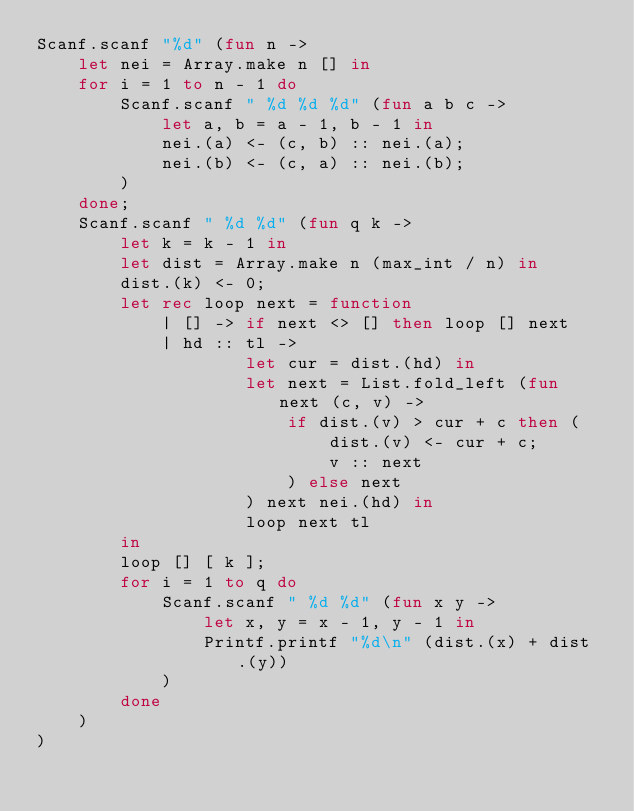<code> <loc_0><loc_0><loc_500><loc_500><_OCaml_>Scanf.scanf "%d" (fun n ->
    let nei = Array.make n [] in
    for i = 1 to n - 1 do
        Scanf.scanf " %d %d %d" (fun a b c ->
            let a, b = a - 1, b - 1 in
            nei.(a) <- (c, b) :: nei.(a);
            nei.(b) <- (c, a) :: nei.(b);
        )
    done;
    Scanf.scanf " %d %d" (fun q k ->
        let k = k - 1 in
        let dist = Array.make n (max_int / n) in
        dist.(k) <- 0;
        let rec loop next = function
            | [] -> if next <> [] then loop [] next
            | hd :: tl ->
                    let cur = dist.(hd) in
                    let next = List.fold_left (fun next (c, v) ->
                        if dist.(v) > cur + c then (
                            dist.(v) <- cur + c;
                            v :: next
                        ) else next
                    ) next nei.(hd) in
                    loop next tl
        in
        loop [] [ k ];
        for i = 1 to q do
            Scanf.scanf " %d %d" (fun x y ->
                let x, y = x - 1, y - 1 in
                Printf.printf "%d\n" (dist.(x) + dist.(y))
            )
        done
    )
)</code> 